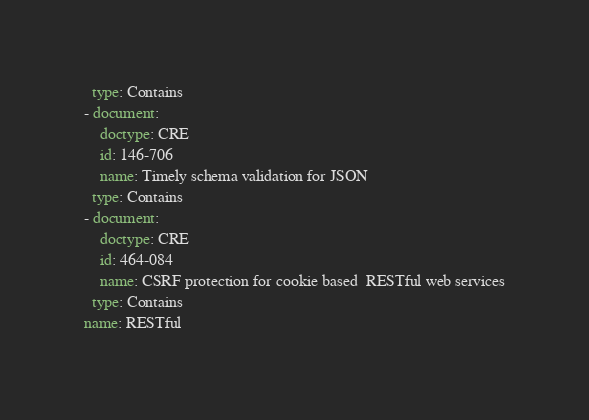<code> <loc_0><loc_0><loc_500><loc_500><_YAML_>  type: Contains
- document:
    doctype: CRE
    id: 146-706
    name: Timely schema validation for JSON
  type: Contains
- document:
    doctype: CRE
    id: 464-084
    name: CSRF protection for cookie based  RESTful web services
  type: Contains
name: RESTful
</code> 